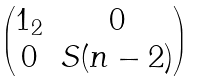<formula> <loc_0><loc_0><loc_500><loc_500>\begin{pmatrix} 1 _ { 2 } & 0 \\ 0 & S ( n - 2 ) \end{pmatrix}</formula> 